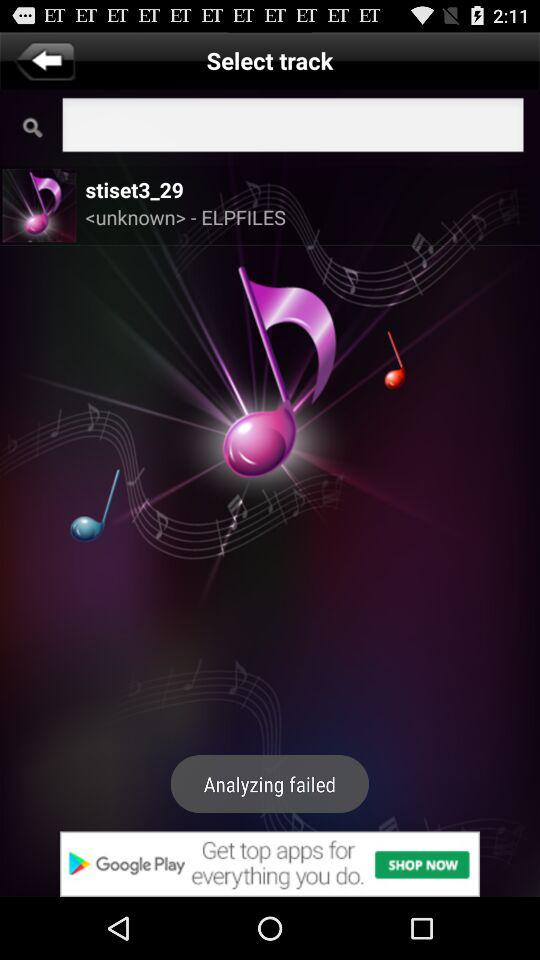Which song has been displayed? The song that has been displayed is "stiset3_29". 